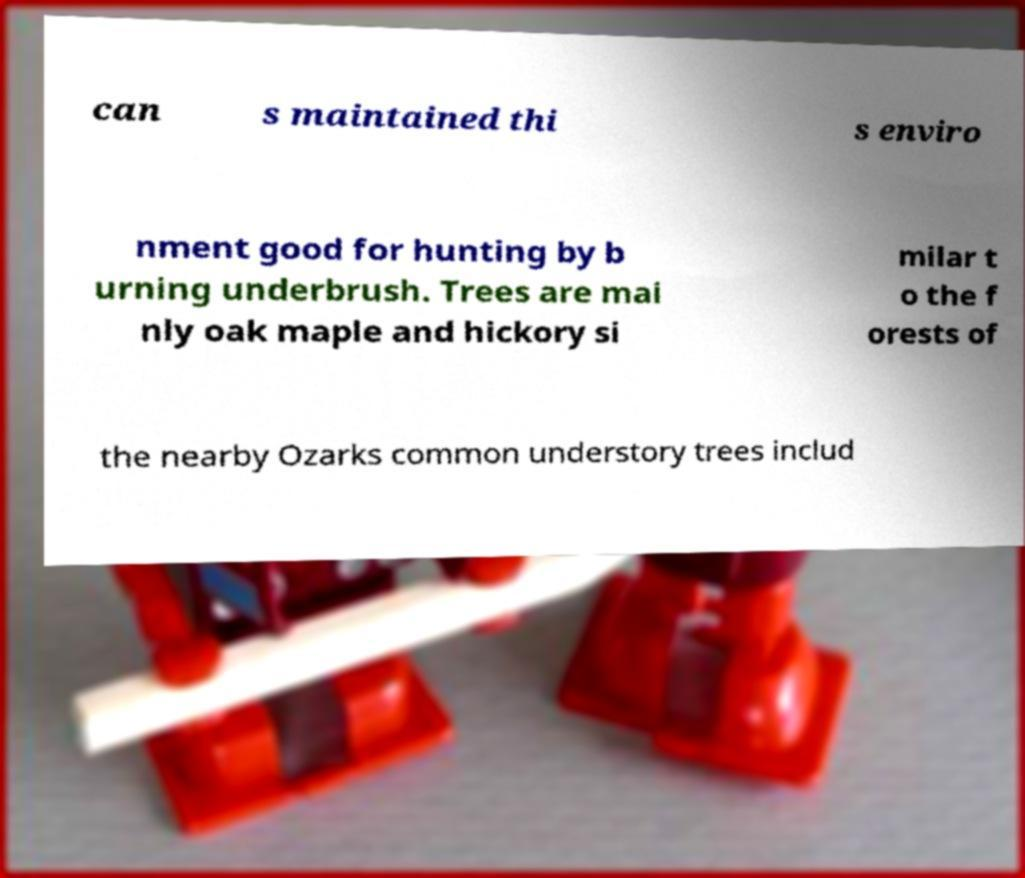What messages or text are displayed in this image? I need them in a readable, typed format. can s maintained thi s enviro nment good for hunting by b urning underbrush. Trees are mai nly oak maple and hickory si milar t o the f orests of the nearby Ozarks common understory trees includ 